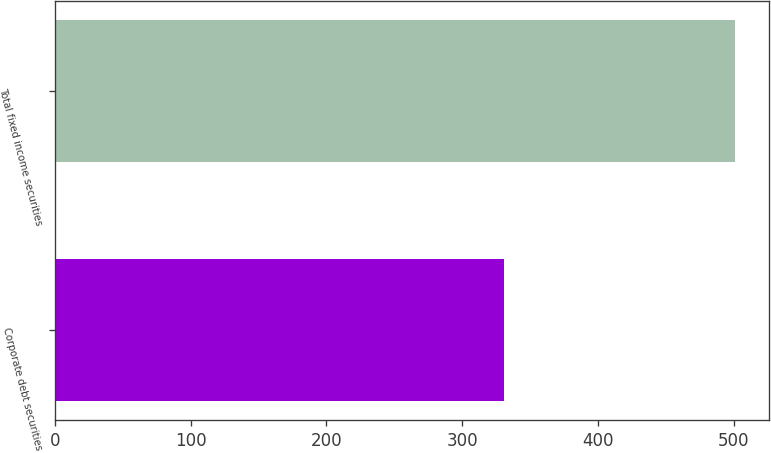Convert chart. <chart><loc_0><loc_0><loc_500><loc_500><bar_chart><fcel>Corporate debt securities<fcel>Total fixed income securities<nl><fcel>330.7<fcel>500.8<nl></chart> 